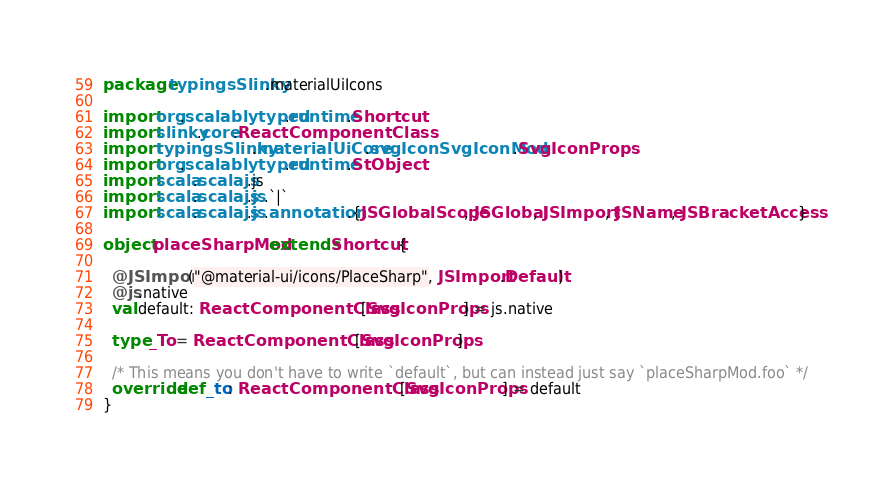<code> <loc_0><loc_0><loc_500><loc_500><_Scala_>package typingsSlinky.materialUiIcons

import org.scalablytyped.runtime.Shortcut
import slinky.core.ReactComponentClass
import typingsSlinky.materialUiCore.svgIconSvgIconMod.SvgIconProps
import org.scalablytyped.runtime.StObject
import scala.scalajs.js
import scala.scalajs.js.`|`
import scala.scalajs.js.annotation.{JSGlobalScope, JSGlobal, JSImport, JSName, JSBracketAccess}

object placeSharpMod extends Shortcut {
  
  @JSImport("@material-ui/icons/PlaceSharp", JSImport.Default)
  @js.native
  val default: ReactComponentClass[SvgIconProps] = js.native
  
  type _To = ReactComponentClass[SvgIconProps]
  
  /* This means you don't have to write `default`, but can instead just say `placeSharpMod.foo` */
  override def _to: ReactComponentClass[SvgIconProps] = default
}
</code> 